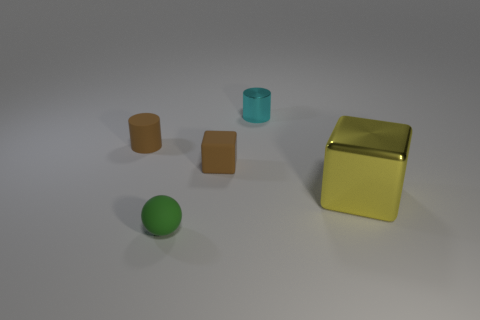Are there any tiny things that have the same shape as the large object?
Your response must be concise. Yes. There is a small shiny thing that is on the left side of the large metallic cube; is its shape the same as the rubber object that is behind the tiny cube?
Give a very brief answer. Yes. What is the material of the cyan cylinder that is the same size as the brown cube?
Make the answer very short. Metal. How many other objects are the same material as the cyan cylinder?
Offer a very short reply. 1. What shape is the matte object left of the tiny rubber object in front of the brown rubber cube?
Your answer should be very brief. Cylinder. What number of objects are either big cyan objects or tiny cylinders that are left of the cyan cylinder?
Provide a succinct answer. 1. What number of other things are the same color as the big metallic block?
Give a very brief answer. 0. How many cyan things are either small things or big shiny blocks?
Offer a terse response. 1. Is there a cyan metallic cylinder right of the tiny cylinder right of the brown rubber object that is on the left side of the rubber ball?
Give a very brief answer. No. Are there any other things that are the same size as the yellow object?
Offer a terse response. No. 